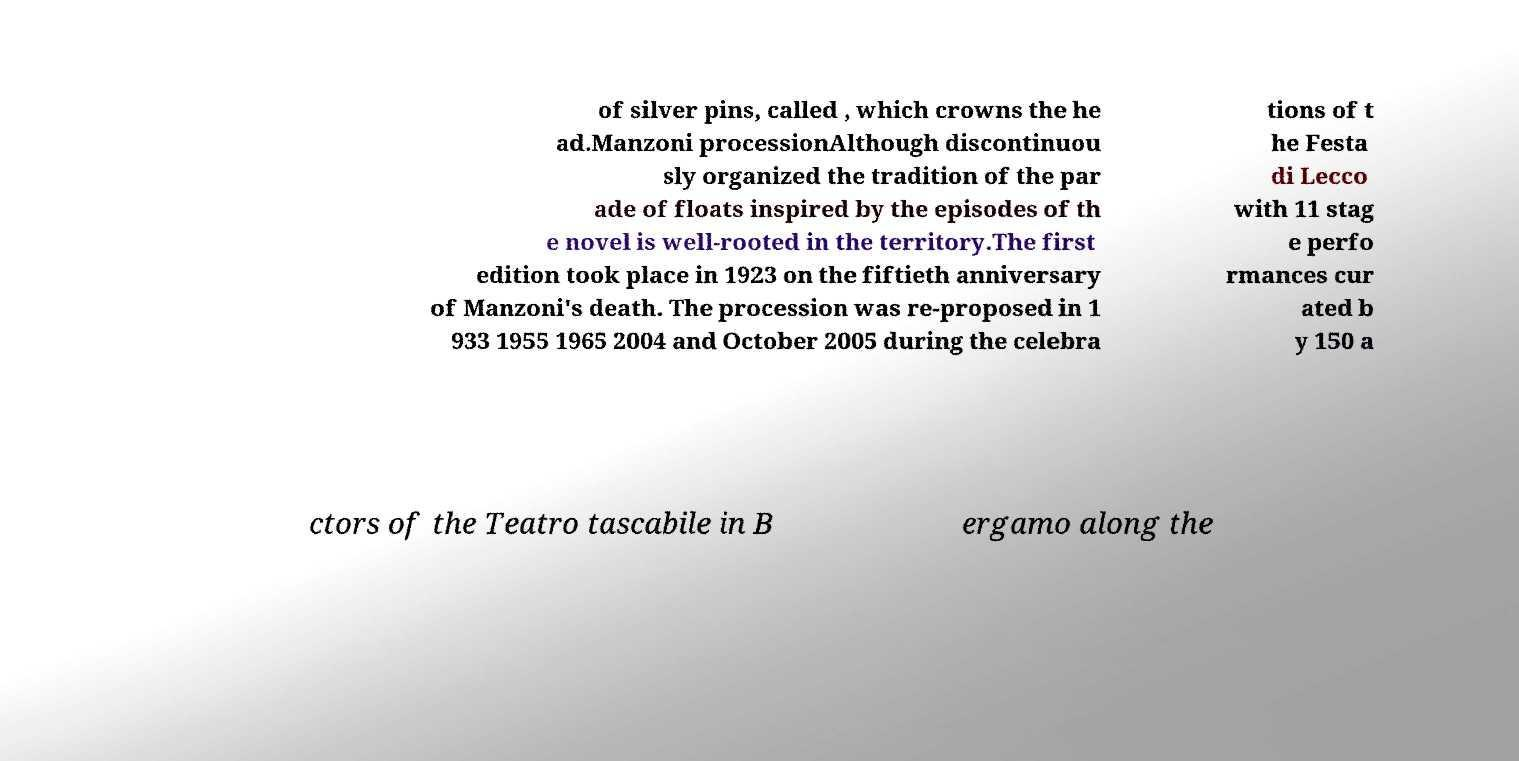There's text embedded in this image that I need extracted. Can you transcribe it verbatim? of silver pins, called , which crowns the he ad.Manzoni processionAlthough discontinuou sly organized the tradition of the par ade of floats inspired by the episodes of th e novel is well-rooted in the territory.The first edition took place in 1923 on the fiftieth anniversary of Manzoni's death. The procession was re-proposed in 1 933 1955 1965 2004 and October 2005 during the celebra tions of t he Festa di Lecco with 11 stag e perfo rmances cur ated b y 150 a ctors of the Teatro tascabile in B ergamo along the 